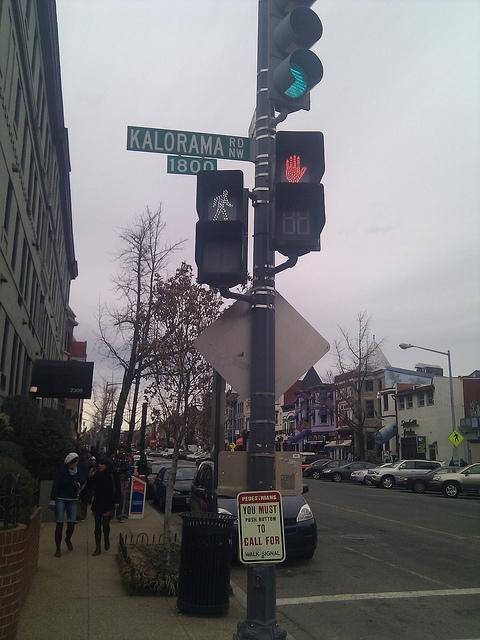The first three letters of the name of the street form the first name of what actor?
Select the accurate answer and provide justification: `Answer: choice
Rationale: srationale.`
Options: Jim beaver, kal penn, joe pesci, michael keaton. Answer: kal penn.
Rationale: It's the only one to match. 